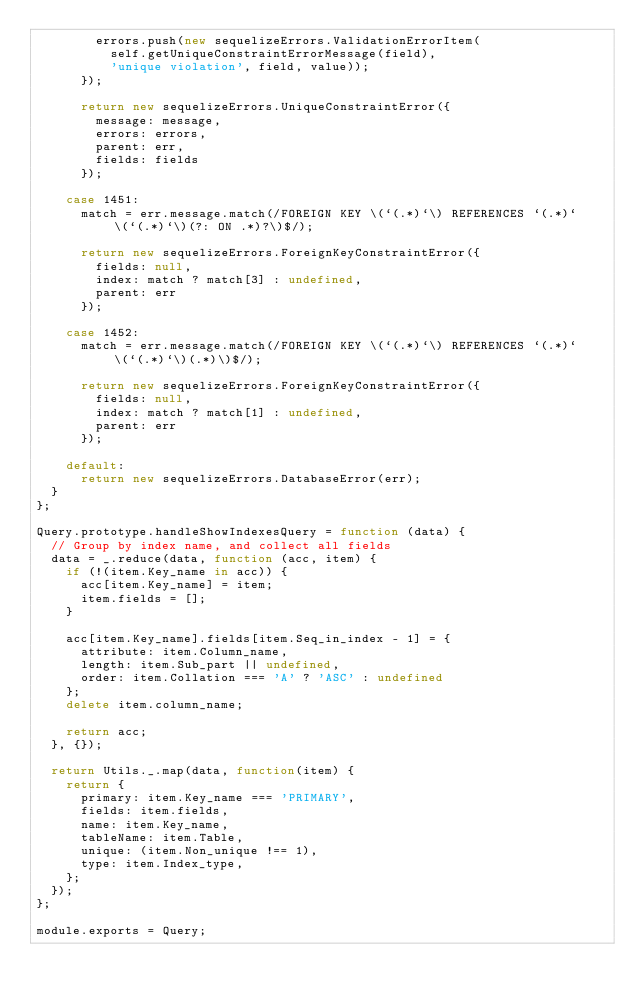<code> <loc_0><loc_0><loc_500><loc_500><_JavaScript_>        errors.push(new sequelizeErrors.ValidationErrorItem(
          self.getUniqueConstraintErrorMessage(field),
          'unique violation', field, value));
      });

      return new sequelizeErrors.UniqueConstraintError({
        message: message,
        errors: errors,
        parent: err,
        fields: fields
      });

    case 1451:
      match = err.message.match(/FOREIGN KEY \(`(.*)`\) REFERENCES `(.*)` \(`(.*)`\)(?: ON .*)?\)$/);

      return new sequelizeErrors.ForeignKeyConstraintError({
        fields: null,
        index: match ? match[3] : undefined,
        parent: err
      });

    case 1452:
      match = err.message.match(/FOREIGN KEY \(`(.*)`\) REFERENCES `(.*)` \(`(.*)`\)(.*)\)$/);

      return new sequelizeErrors.ForeignKeyConstraintError({
        fields: null,
        index: match ? match[1] : undefined,
        parent: err
      });

    default:
      return new sequelizeErrors.DatabaseError(err);
  }
};

Query.prototype.handleShowIndexesQuery = function (data) {
  // Group by index name, and collect all fields
  data = _.reduce(data, function (acc, item) {
    if (!(item.Key_name in acc)) {
      acc[item.Key_name] = item;
      item.fields = [];
    }

    acc[item.Key_name].fields[item.Seq_in_index - 1] = {
      attribute: item.Column_name,
      length: item.Sub_part || undefined,
      order: item.Collation === 'A' ? 'ASC' : undefined
    };
    delete item.column_name;

    return acc;
  }, {});

  return Utils._.map(data, function(item) {
    return {
      primary: item.Key_name === 'PRIMARY',
      fields: item.fields,
      name: item.Key_name,
      tableName: item.Table,
      unique: (item.Non_unique !== 1),
      type: item.Index_type,
    };
  });
};

module.exports = Query;
</code> 